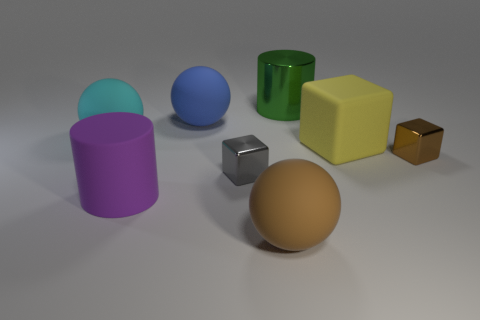Add 1 gray metal blocks. How many objects exist? 9 Subtract all spheres. How many objects are left? 5 Add 1 big cyan matte objects. How many big cyan matte objects are left? 2 Add 5 yellow cylinders. How many yellow cylinders exist? 5 Subtract 0 red cylinders. How many objects are left? 8 Subtract all big gray matte cylinders. Subtract all small things. How many objects are left? 6 